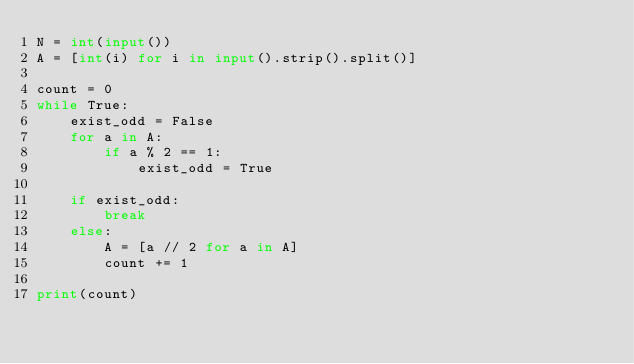Convert code to text. <code><loc_0><loc_0><loc_500><loc_500><_Python_>N = int(input())
A = [int(i) for i in input().strip().split()]

count = 0
while True:
    exist_odd = False
    for a in A:
        if a % 2 == 1:
            exist_odd = True

    if exist_odd:
        break
    else:
        A = [a // 2 for a in A]
        count += 1

print(count)
</code> 